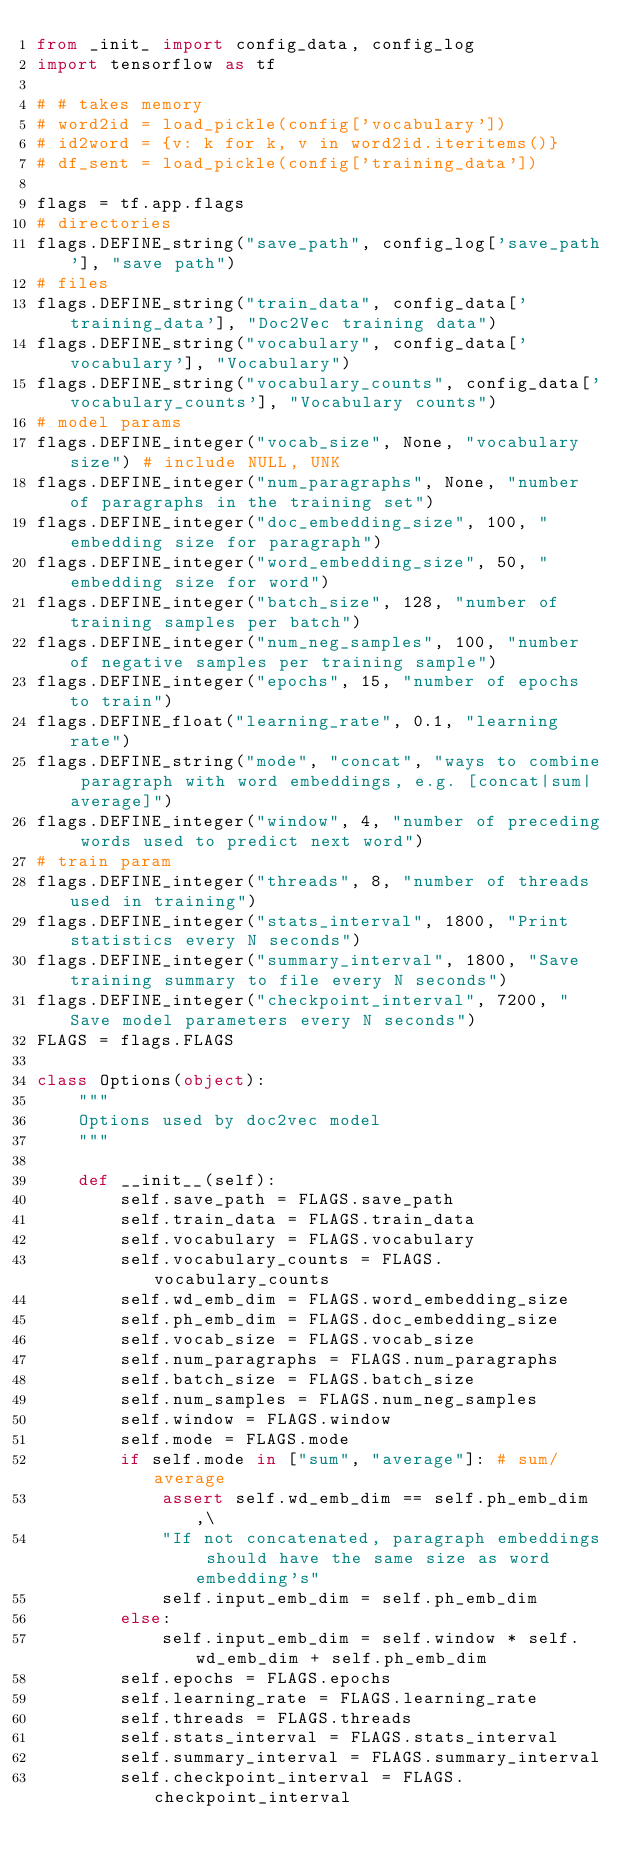Convert code to text. <code><loc_0><loc_0><loc_500><loc_500><_Python_>from _init_ import config_data, config_log
import tensorflow as tf

# # takes memory
# word2id = load_pickle(config['vocabulary'])
# id2word = {v: k for k, v in word2id.iteritems()}
# df_sent = load_pickle(config['training_data'])

flags = tf.app.flags
# directories
flags.DEFINE_string("save_path", config_log['save_path'], "save path")
# files
flags.DEFINE_string("train_data", config_data['training_data'], "Doc2Vec training data")
flags.DEFINE_string("vocabulary", config_data['vocabulary'], "Vocabulary")
flags.DEFINE_string("vocabulary_counts", config_data['vocabulary_counts'], "Vocabulary counts")
# model params
flags.DEFINE_integer("vocab_size", None, "vocabulary size") # include NULL, UNK
flags.DEFINE_integer("num_paragraphs", None, "number of paragraphs in the training set")
flags.DEFINE_integer("doc_embedding_size", 100, "embedding size for paragraph")
flags.DEFINE_integer("word_embedding_size", 50, "embedding size for word")
flags.DEFINE_integer("batch_size", 128, "number of training samples per batch")
flags.DEFINE_integer("num_neg_samples", 100, "number of negative samples per training sample")
flags.DEFINE_integer("epochs", 15, "number of epochs to train")
flags.DEFINE_float("learning_rate", 0.1, "learning rate")
flags.DEFINE_string("mode", "concat", "ways to combine paragraph with word embeddings, e.g. [concat|sum|average]")
flags.DEFINE_integer("window", 4, "number of preceding words used to predict next word")
# train param
flags.DEFINE_integer("threads", 8, "number of threads used in training")
flags.DEFINE_integer("stats_interval", 1800, "Print statistics every N seconds")
flags.DEFINE_integer("summary_interval", 1800, "Save training summary to file every N seconds")
flags.DEFINE_integer("checkpoint_interval", 7200, "Save model parameters every N seconds")
FLAGS = flags.FLAGS

class Options(object):
    """
    Options used by doc2vec model
    """

    def __init__(self):
        self.save_path = FLAGS.save_path
        self.train_data = FLAGS.train_data
        self.vocabulary = FLAGS.vocabulary
        self.vocabulary_counts = FLAGS.vocabulary_counts
        self.wd_emb_dim = FLAGS.word_embedding_size
        self.ph_emb_dim = FLAGS.doc_embedding_size
        self.vocab_size = FLAGS.vocab_size
        self.num_paragraphs = FLAGS.num_paragraphs
        self.batch_size = FLAGS.batch_size
        self.num_samples = FLAGS.num_neg_samples
        self.window = FLAGS.window
        self.mode = FLAGS.mode
        if self.mode in ["sum", "average"]: # sum/average
            assert self.wd_emb_dim == self.ph_emb_dim,\
            "If not concatenated, paragraph embeddings should have the same size as word embedding's"
            self.input_emb_dim = self.ph_emb_dim
        else:
            self.input_emb_dim = self.window * self.wd_emb_dim + self.ph_emb_dim
        self.epochs = FLAGS.epochs
        self.learning_rate = FLAGS.learning_rate
        self.threads = FLAGS.threads
        self.stats_interval = FLAGS.stats_interval
        self.summary_interval = FLAGS.summary_interval
        self.checkpoint_interval = FLAGS.checkpoint_interval</code> 